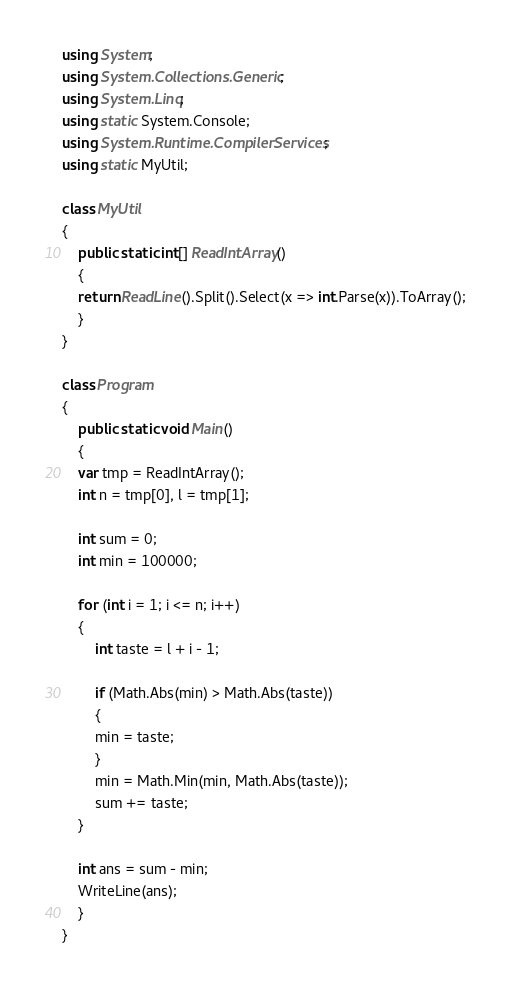<code> <loc_0><loc_0><loc_500><loc_500><_C#_>using System;
using System.Collections.Generic;
using System.Linq;
using static System.Console;
using System.Runtime.CompilerServices;
using static MyUtil;

class MyUtil
{
    public static int[] ReadIntArray()
    {
	return ReadLine().Split().Select(x => int.Parse(x)).ToArray();
    }
}

class Program
{
    public static void Main()
    {
	var tmp = ReadIntArray();
	int n = tmp[0], l = tmp[1];

	int sum = 0;
	int min = 100000;

	for (int i = 1; i <= n; i++)
	{
	    int taste = l + i - 1;

	    if (Math.Abs(min) > Math.Abs(taste))
	    {
		min = taste;
	    }
	    min = Math.Min(min, Math.Abs(taste));
	    sum += taste;
	}

	int ans = sum - min;
	WriteLine(ans);
    }
}
</code> 